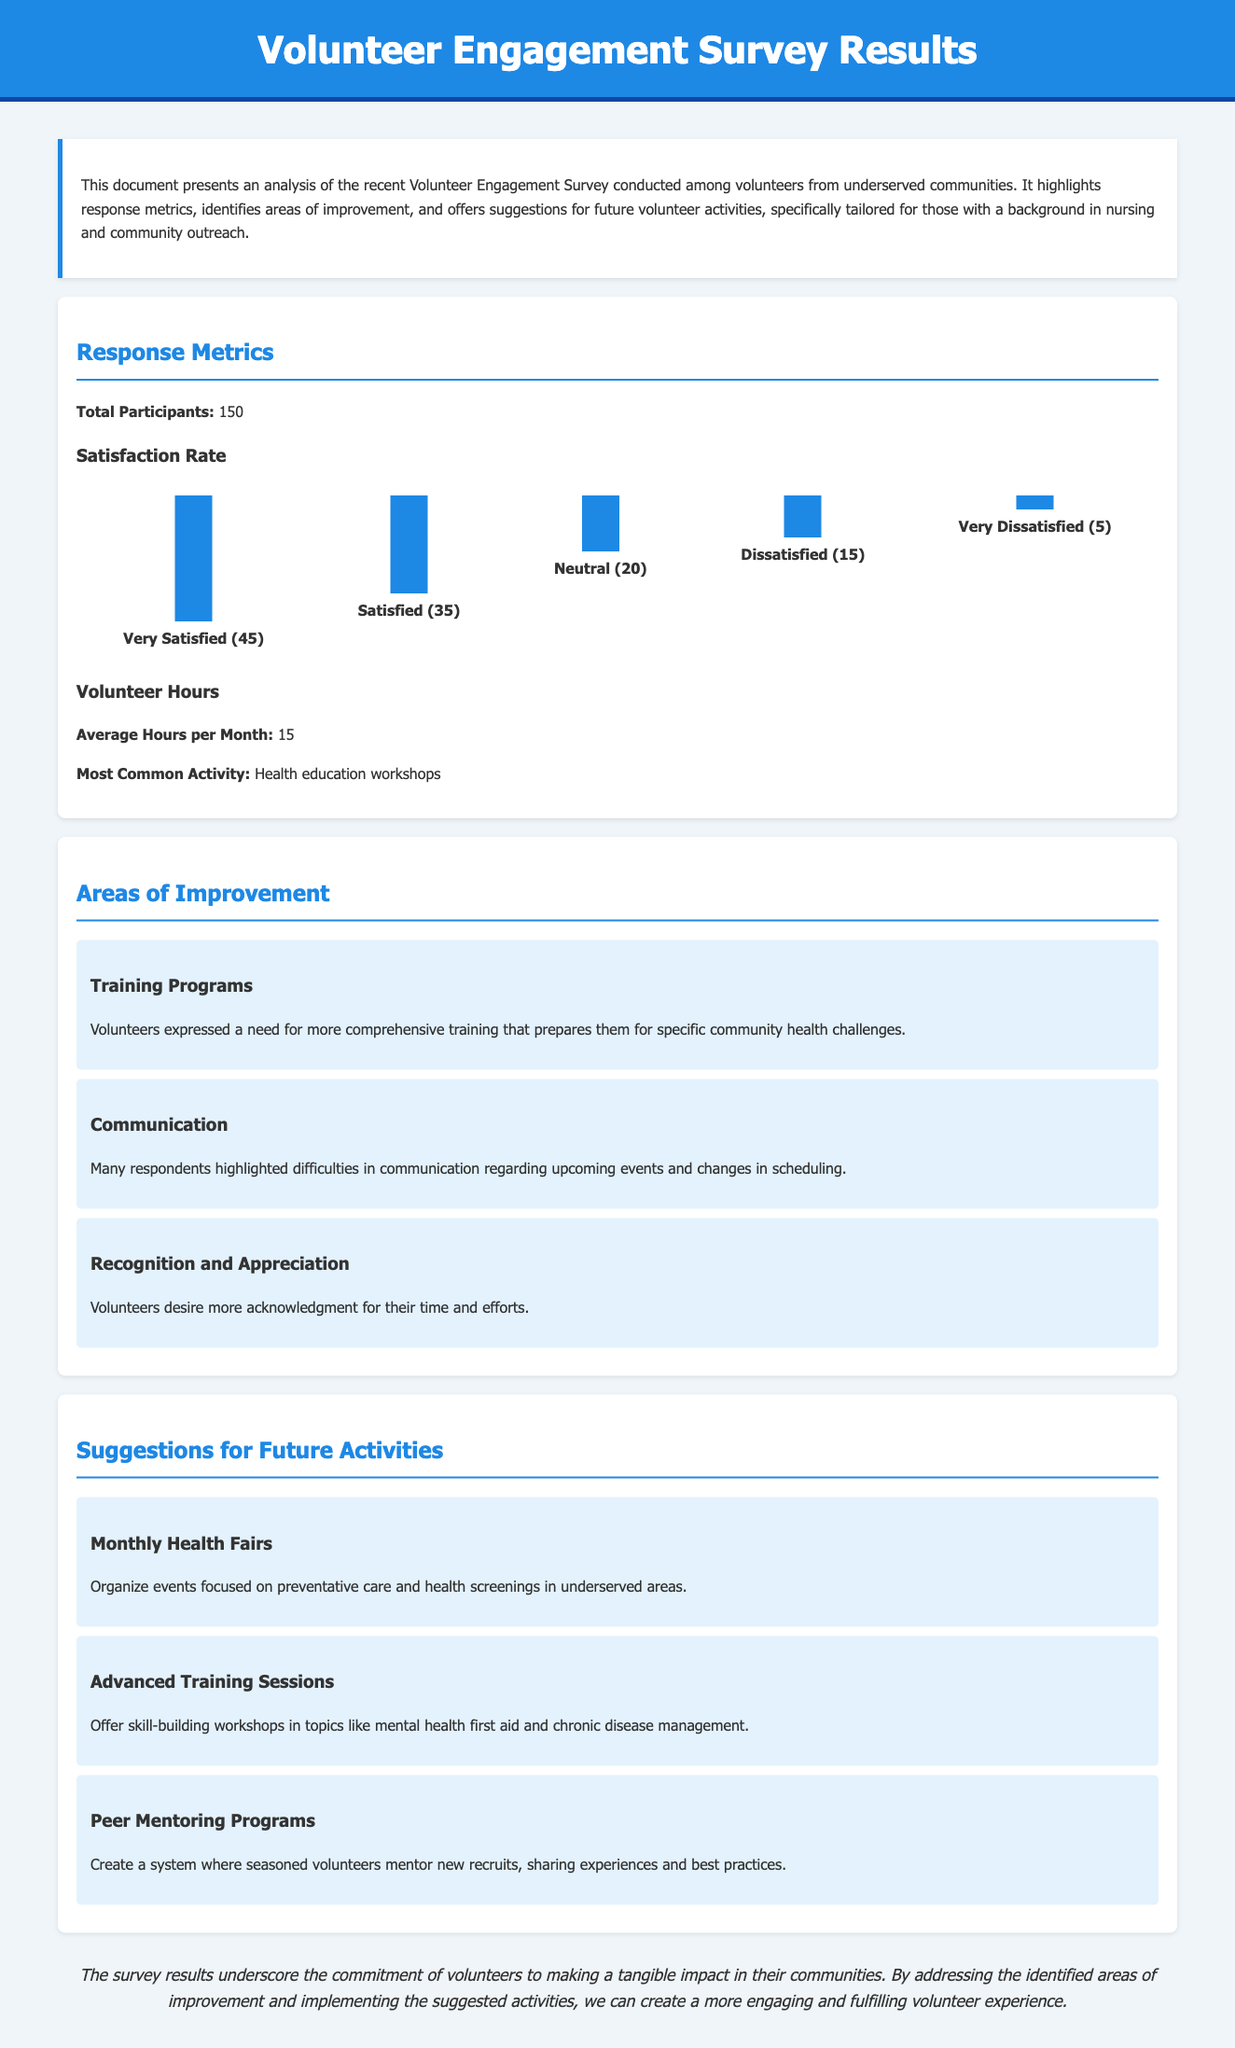what is the total number of participants? The total number of participants in the survey is specified in the document as 150.
Answer: 150 what percentage of volunteers are very satisfied? The satisfaction metrics show that 45 out of 150 participants reported being very satisfied, leading to a calculation of 30%.
Answer: 30% what is the most common volunteer activity mentioned? The document notes that the most common activity among volunteers is health education workshops.
Answer: health education workshops what area needs improvement according to the volunteers? Volunteers expressed a need for improvement regarding training programs as indicated in the document.
Answer: Training Programs what suggestion for future activities involves health screenings? The section on suggestions recommends organizing monthly health fairs focused on preventative care and health screenings.
Answer: Monthly Health Fairs how many volunteers reported being dissatisfied? The document states that 15 volunteers reported being dissatisfied with their experience.
Answer: 15 what is the average number of volunteer hours per month? The document provides the average hours volunteers dedicate per month as 15.
Answer: 15 what do volunteers desire more of for their efforts? Volunteers desire more recognition and appreciation for their time and efforts, as highlighted in the document.
Answer: Recognition and Appreciation 